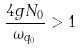Convert formula to latex. <formula><loc_0><loc_0><loc_500><loc_500>\frac { 4 g N _ { 0 } } { \omega _ { q _ { 0 } } } > 1</formula> 